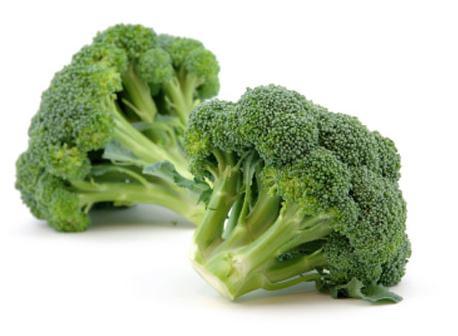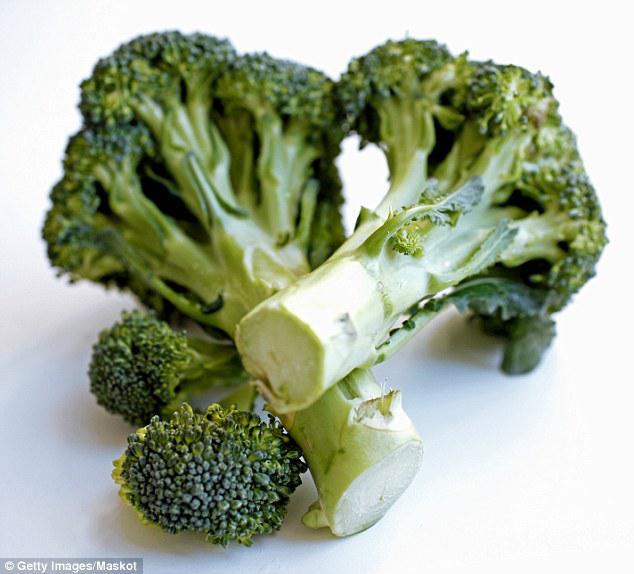The first image is the image on the left, the second image is the image on the right. Given the left and right images, does the statement "A total of three cut broccoli florets are shown." hold true? Answer yes or no. No. 